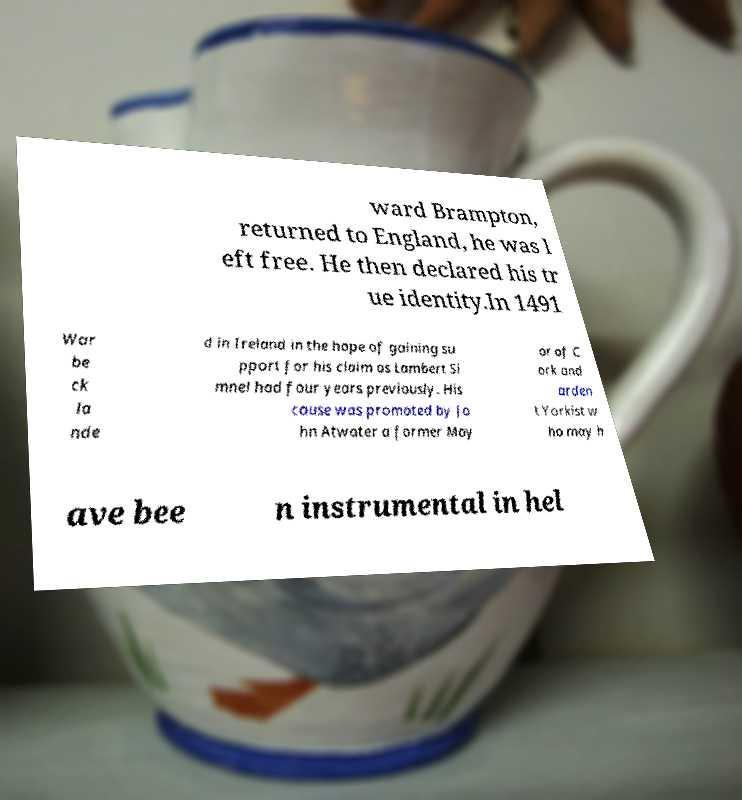Please read and relay the text visible in this image. What does it say? ward Brampton, returned to England, he was l eft free. He then declared his tr ue identity.In 1491 War be ck la nde d in Ireland in the hope of gaining su pport for his claim as Lambert Si mnel had four years previously. His cause was promoted by Jo hn Atwater a former May or of C ork and arden t Yorkist w ho may h ave bee n instrumental in hel 